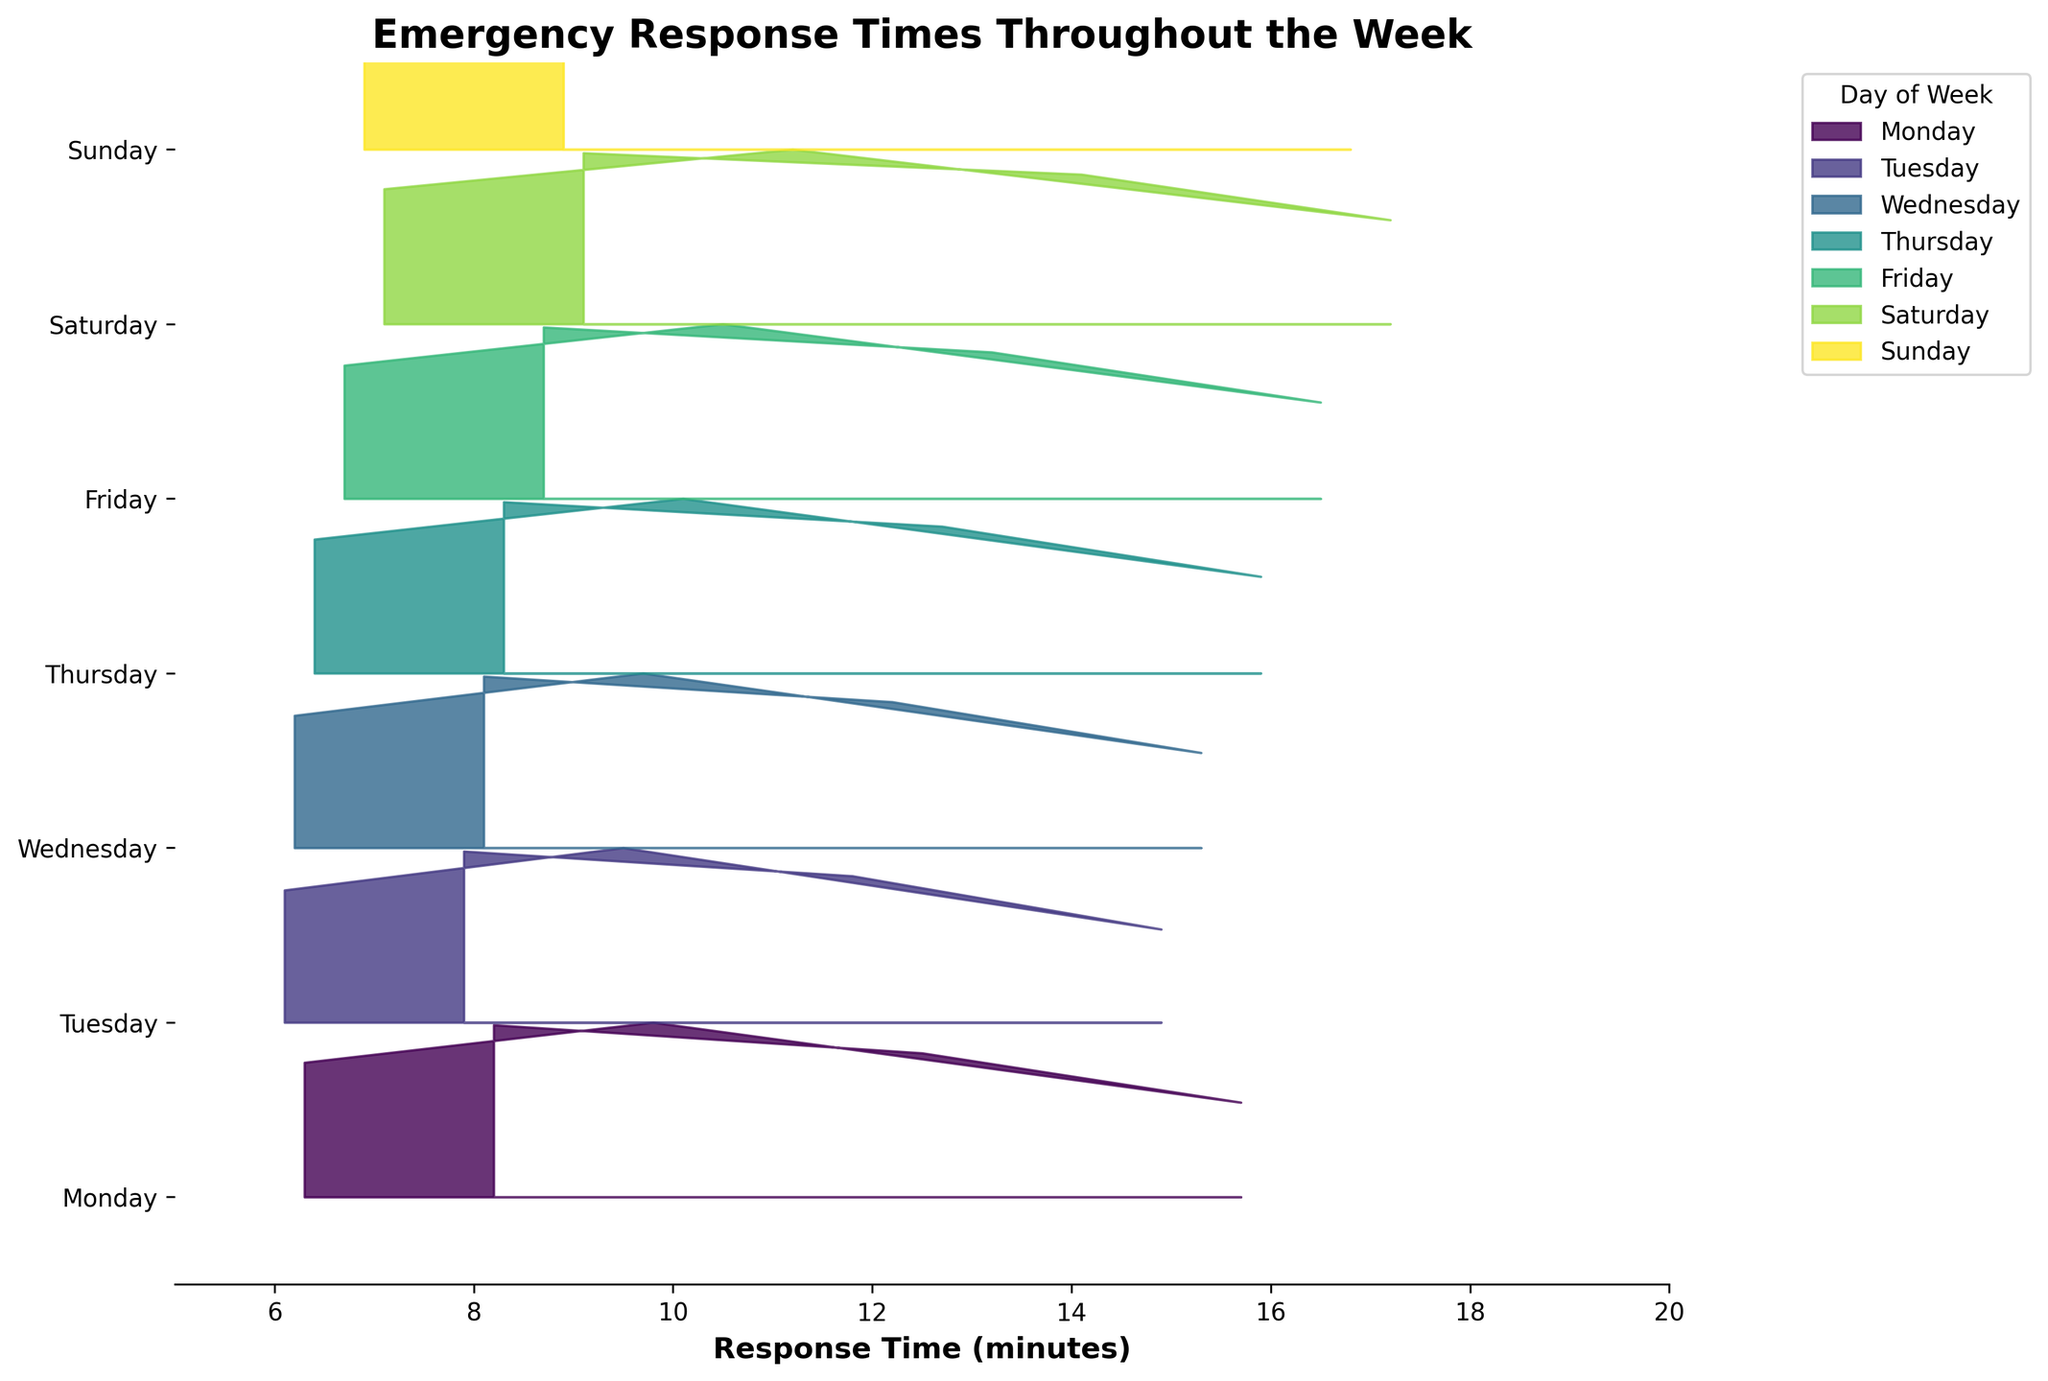What's the title of the plot? The title of the plot is found at the top of the figure in bold, indicating the subject of the visualization.
Answer: Emergency Response Times Throughout the Week Which day shows the fastest overall response time for emergency calls? By looking at the plot, you can compare the peak densities or filled areas. The lowest valleys or peaks generally indicate faster response times.
Answer: Medical Emergency on Monday How does the response time for Domestic Violence calls change from Monday to Saturday? Compare the position and height of the ridgelines for Domestic Violence calls from Monday to Saturday, observing any shifts to the right or changes in height.
Answer: Increases Which emergency call type has the longest response time on Friday? Look specifically at Friday's section in the plot and identify which colored ridgeline or peak extends furthest to the right, indicating longer response time.
Answer: Burglary On which day are traffic accident response times most similar? Look for the consistency or similarity in the height and shape of the ridgeline for traffic accidents across all days. Identify the day where the shape and spread are most average or consistent.
Answer: Tuesday Are assault response times more consistent on Wednesday or Sunday? Observe the spread and variations in the ridgelines for assault calls on Wednesday and Sunday. Consistency is indicated by less variability in the curve's spread.
Answer: Wednesday Which day has the highest peak density for Medical Emergencies? Identify the tallest peak in the ridgelines specifically for Medical Emergencies, indicating the highest density of response times.
Answer: Monday Is the average response time for burglaries higher on Saturday compared to Tuesday? Compare the position of the bulk of the ridgeline for burglaries on Saturday against Tuesday. The average will be where the bulk of the density lies.
Answer: Yes How does the spread of response times for traffic accidents differ between Wednesday and Sunday? Analyze the width of the ridgelines for traffic accidents on both days. A wider spread indicates more variability, while a narrower spread indicates less variability.
Answer: Greater spread on Sunday Do medical emergencies have quicker response times compared to traffic accidents across all days? Examine the ridgelines for medical emergencies and traffic accidents. Compare their positions; medical emergencies should consistently have ridgelines shifted to the left (quicker times).
Answer: Yes 